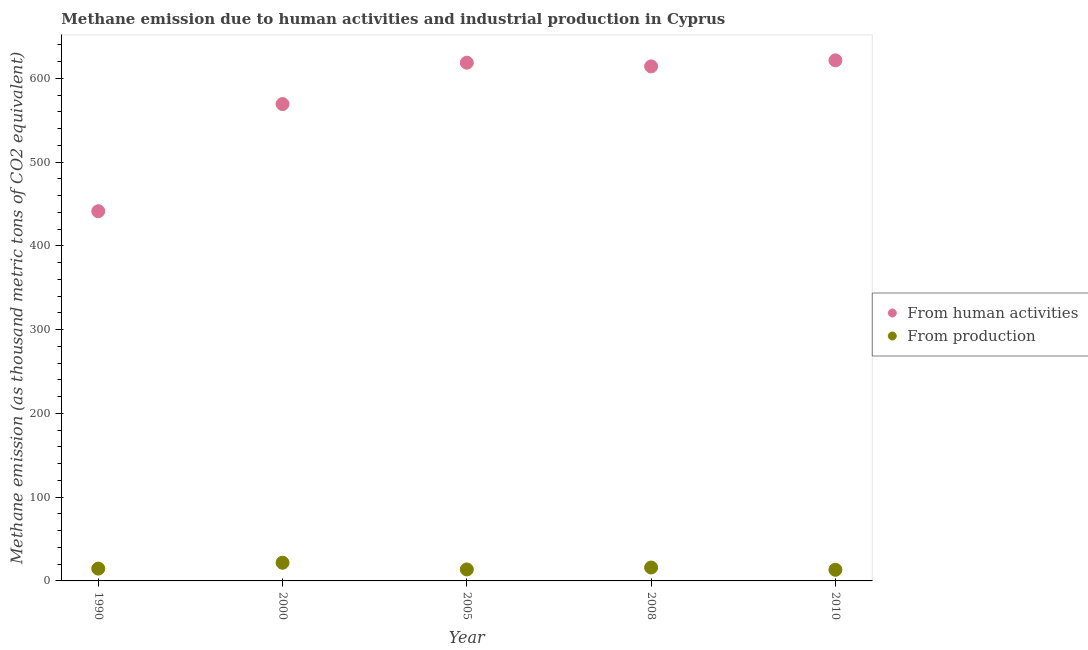Is the number of dotlines equal to the number of legend labels?
Make the answer very short. Yes. What is the amount of emissions generated from industries in 2010?
Make the answer very short. 13.3. Across all years, what is the maximum amount of emissions generated from industries?
Provide a succinct answer. 21.7. Across all years, what is the minimum amount of emissions generated from industries?
Provide a short and direct response. 13.3. In which year was the amount of emissions generated from industries minimum?
Provide a short and direct response. 2010. What is the total amount of emissions from human activities in the graph?
Your answer should be compact. 2864.7. What is the difference between the amount of emissions generated from industries in 2010 and the amount of emissions from human activities in 1990?
Offer a very short reply. -428. What is the average amount of emissions from human activities per year?
Keep it short and to the point. 572.94. In the year 2008, what is the difference between the amount of emissions generated from industries and amount of emissions from human activities?
Give a very brief answer. -598.2. What is the ratio of the amount of emissions generated from industries in 2000 to that in 2008?
Offer a terse response. 1.36. Is the amount of emissions generated from industries in 2000 less than that in 2008?
Provide a short and direct response. No. What is the difference between the highest and the second highest amount of emissions generated from industries?
Offer a very short reply. 5.7. What is the difference between the highest and the lowest amount of emissions from human activities?
Your response must be concise. 180.1. Is the sum of the amount of emissions generated from industries in 2008 and 2010 greater than the maximum amount of emissions from human activities across all years?
Keep it short and to the point. No. How many dotlines are there?
Offer a very short reply. 2. What is the difference between two consecutive major ticks on the Y-axis?
Offer a terse response. 100. How are the legend labels stacked?
Offer a very short reply. Vertical. What is the title of the graph?
Make the answer very short. Methane emission due to human activities and industrial production in Cyprus. Does "International Visitors" appear as one of the legend labels in the graph?
Offer a very short reply. No. What is the label or title of the X-axis?
Your answer should be very brief. Year. What is the label or title of the Y-axis?
Your answer should be compact. Methane emission (as thousand metric tons of CO2 equivalent). What is the Methane emission (as thousand metric tons of CO2 equivalent) in From human activities in 1990?
Make the answer very short. 441.3. What is the Methane emission (as thousand metric tons of CO2 equivalent) of From human activities in 2000?
Your answer should be compact. 569.2. What is the Methane emission (as thousand metric tons of CO2 equivalent) of From production in 2000?
Your answer should be compact. 21.7. What is the Methane emission (as thousand metric tons of CO2 equivalent) in From human activities in 2005?
Offer a very short reply. 618.6. What is the Methane emission (as thousand metric tons of CO2 equivalent) of From human activities in 2008?
Make the answer very short. 614.2. What is the Methane emission (as thousand metric tons of CO2 equivalent) in From human activities in 2010?
Your answer should be compact. 621.4. Across all years, what is the maximum Methane emission (as thousand metric tons of CO2 equivalent) of From human activities?
Your answer should be very brief. 621.4. Across all years, what is the maximum Methane emission (as thousand metric tons of CO2 equivalent) in From production?
Make the answer very short. 21.7. Across all years, what is the minimum Methane emission (as thousand metric tons of CO2 equivalent) in From human activities?
Keep it short and to the point. 441.3. What is the total Methane emission (as thousand metric tons of CO2 equivalent) in From human activities in the graph?
Your answer should be compact. 2864.7. What is the total Methane emission (as thousand metric tons of CO2 equivalent) in From production in the graph?
Provide a short and direct response. 79.4. What is the difference between the Methane emission (as thousand metric tons of CO2 equivalent) of From human activities in 1990 and that in 2000?
Offer a terse response. -127.9. What is the difference between the Methane emission (as thousand metric tons of CO2 equivalent) in From production in 1990 and that in 2000?
Provide a short and direct response. -7. What is the difference between the Methane emission (as thousand metric tons of CO2 equivalent) in From human activities in 1990 and that in 2005?
Offer a very short reply. -177.3. What is the difference between the Methane emission (as thousand metric tons of CO2 equivalent) of From production in 1990 and that in 2005?
Keep it short and to the point. 1. What is the difference between the Methane emission (as thousand metric tons of CO2 equivalent) in From human activities in 1990 and that in 2008?
Your answer should be very brief. -172.9. What is the difference between the Methane emission (as thousand metric tons of CO2 equivalent) of From production in 1990 and that in 2008?
Offer a very short reply. -1.3. What is the difference between the Methane emission (as thousand metric tons of CO2 equivalent) of From human activities in 1990 and that in 2010?
Ensure brevity in your answer.  -180.1. What is the difference between the Methane emission (as thousand metric tons of CO2 equivalent) of From human activities in 2000 and that in 2005?
Your answer should be very brief. -49.4. What is the difference between the Methane emission (as thousand metric tons of CO2 equivalent) of From human activities in 2000 and that in 2008?
Your answer should be compact. -45. What is the difference between the Methane emission (as thousand metric tons of CO2 equivalent) in From human activities in 2000 and that in 2010?
Your response must be concise. -52.2. What is the difference between the Methane emission (as thousand metric tons of CO2 equivalent) in From production in 2005 and that in 2008?
Keep it short and to the point. -2.3. What is the difference between the Methane emission (as thousand metric tons of CO2 equivalent) in From human activities in 2005 and that in 2010?
Keep it short and to the point. -2.8. What is the difference between the Methane emission (as thousand metric tons of CO2 equivalent) of From production in 2005 and that in 2010?
Give a very brief answer. 0.4. What is the difference between the Methane emission (as thousand metric tons of CO2 equivalent) of From human activities in 1990 and the Methane emission (as thousand metric tons of CO2 equivalent) of From production in 2000?
Your answer should be compact. 419.6. What is the difference between the Methane emission (as thousand metric tons of CO2 equivalent) of From human activities in 1990 and the Methane emission (as thousand metric tons of CO2 equivalent) of From production in 2005?
Offer a terse response. 427.6. What is the difference between the Methane emission (as thousand metric tons of CO2 equivalent) in From human activities in 1990 and the Methane emission (as thousand metric tons of CO2 equivalent) in From production in 2008?
Give a very brief answer. 425.3. What is the difference between the Methane emission (as thousand metric tons of CO2 equivalent) in From human activities in 1990 and the Methane emission (as thousand metric tons of CO2 equivalent) in From production in 2010?
Offer a very short reply. 428. What is the difference between the Methane emission (as thousand metric tons of CO2 equivalent) of From human activities in 2000 and the Methane emission (as thousand metric tons of CO2 equivalent) of From production in 2005?
Make the answer very short. 555.5. What is the difference between the Methane emission (as thousand metric tons of CO2 equivalent) in From human activities in 2000 and the Methane emission (as thousand metric tons of CO2 equivalent) in From production in 2008?
Give a very brief answer. 553.2. What is the difference between the Methane emission (as thousand metric tons of CO2 equivalent) of From human activities in 2000 and the Methane emission (as thousand metric tons of CO2 equivalent) of From production in 2010?
Your response must be concise. 555.9. What is the difference between the Methane emission (as thousand metric tons of CO2 equivalent) in From human activities in 2005 and the Methane emission (as thousand metric tons of CO2 equivalent) in From production in 2008?
Offer a very short reply. 602.6. What is the difference between the Methane emission (as thousand metric tons of CO2 equivalent) of From human activities in 2005 and the Methane emission (as thousand metric tons of CO2 equivalent) of From production in 2010?
Give a very brief answer. 605.3. What is the difference between the Methane emission (as thousand metric tons of CO2 equivalent) of From human activities in 2008 and the Methane emission (as thousand metric tons of CO2 equivalent) of From production in 2010?
Your answer should be compact. 600.9. What is the average Methane emission (as thousand metric tons of CO2 equivalent) in From human activities per year?
Provide a short and direct response. 572.94. What is the average Methane emission (as thousand metric tons of CO2 equivalent) of From production per year?
Provide a short and direct response. 15.88. In the year 1990, what is the difference between the Methane emission (as thousand metric tons of CO2 equivalent) in From human activities and Methane emission (as thousand metric tons of CO2 equivalent) in From production?
Make the answer very short. 426.6. In the year 2000, what is the difference between the Methane emission (as thousand metric tons of CO2 equivalent) in From human activities and Methane emission (as thousand metric tons of CO2 equivalent) in From production?
Your answer should be very brief. 547.5. In the year 2005, what is the difference between the Methane emission (as thousand metric tons of CO2 equivalent) of From human activities and Methane emission (as thousand metric tons of CO2 equivalent) of From production?
Give a very brief answer. 604.9. In the year 2008, what is the difference between the Methane emission (as thousand metric tons of CO2 equivalent) in From human activities and Methane emission (as thousand metric tons of CO2 equivalent) in From production?
Provide a short and direct response. 598.2. In the year 2010, what is the difference between the Methane emission (as thousand metric tons of CO2 equivalent) in From human activities and Methane emission (as thousand metric tons of CO2 equivalent) in From production?
Make the answer very short. 608.1. What is the ratio of the Methane emission (as thousand metric tons of CO2 equivalent) in From human activities in 1990 to that in 2000?
Offer a very short reply. 0.78. What is the ratio of the Methane emission (as thousand metric tons of CO2 equivalent) in From production in 1990 to that in 2000?
Offer a very short reply. 0.68. What is the ratio of the Methane emission (as thousand metric tons of CO2 equivalent) of From human activities in 1990 to that in 2005?
Ensure brevity in your answer.  0.71. What is the ratio of the Methane emission (as thousand metric tons of CO2 equivalent) of From production in 1990 to that in 2005?
Ensure brevity in your answer.  1.07. What is the ratio of the Methane emission (as thousand metric tons of CO2 equivalent) of From human activities in 1990 to that in 2008?
Keep it short and to the point. 0.72. What is the ratio of the Methane emission (as thousand metric tons of CO2 equivalent) of From production in 1990 to that in 2008?
Your answer should be compact. 0.92. What is the ratio of the Methane emission (as thousand metric tons of CO2 equivalent) of From human activities in 1990 to that in 2010?
Keep it short and to the point. 0.71. What is the ratio of the Methane emission (as thousand metric tons of CO2 equivalent) of From production in 1990 to that in 2010?
Provide a succinct answer. 1.11. What is the ratio of the Methane emission (as thousand metric tons of CO2 equivalent) in From human activities in 2000 to that in 2005?
Ensure brevity in your answer.  0.92. What is the ratio of the Methane emission (as thousand metric tons of CO2 equivalent) in From production in 2000 to that in 2005?
Provide a short and direct response. 1.58. What is the ratio of the Methane emission (as thousand metric tons of CO2 equivalent) of From human activities in 2000 to that in 2008?
Give a very brief answer. 0.93. What is the ratio of the Methane emission (as thousand metric tons of CO2 equivalent) of From production in 2000 to that in 2008?
Give a very brief answer. 1.36. What is the ratio of the Methane emission (as thousand metric tons of CO2 equivalent) in From human activities in 2000 to that in 2010?
Offer a terse response. 0.92. What is the ratio of the Methane emission (as thousand metric tons of CO2 equivalent) in From production in 2000 to that in 2010?
Your answer should be very brief. 1.63. What is the ratio of the Methane emission (as thousand metric tons of CO2 equivalent) in From human activities in 2005 to that in 2008?
Give a very brief answer. 1.01. What is the ratio of the Methane emission (as thousand metric tons of CO2 equivalent) of From production in 2005 to that in 2008?
Offer a terse response. 0.86. What is the ratio of the Methane emission (as thousand metric tons of CO2 equivalent) of From production in 2005 to that in 2010?
Your answer should be compact. 1.03. What is the ratio of the Methane emission (as thousand metric tons of CO2 equivalent) of From human activities in 2008 to that in 2010?
Provide a succinct answer. 0.99. What is the ratio of the Methane emission (as thousand metric tons of CO2 equivalent) in From production in 2008 to that in 2010?
Provide a short and direct response. 1.2. What is the difference between the highest and the second highest Methane emission (as thousand metric tons of CO2 equivalent) in From human activities?
Your answer should be very brief. 2.8. What is the difference between the highest and the second highest Methane emission (as thousand metric tons of CO2 equivalent) in From production?
Offer a terse response. 5.7. What is the difference between the highest and the lowest Methane emission (as thousand metric tons of CO2 equivalent) of From human activities?
Offer a terse response. 180.1. What is the difference between the highest and the lowest Methane emission (as thousand metric tons of CO2 equivalent) of From production?
Offer a very short reply. 8.4. 